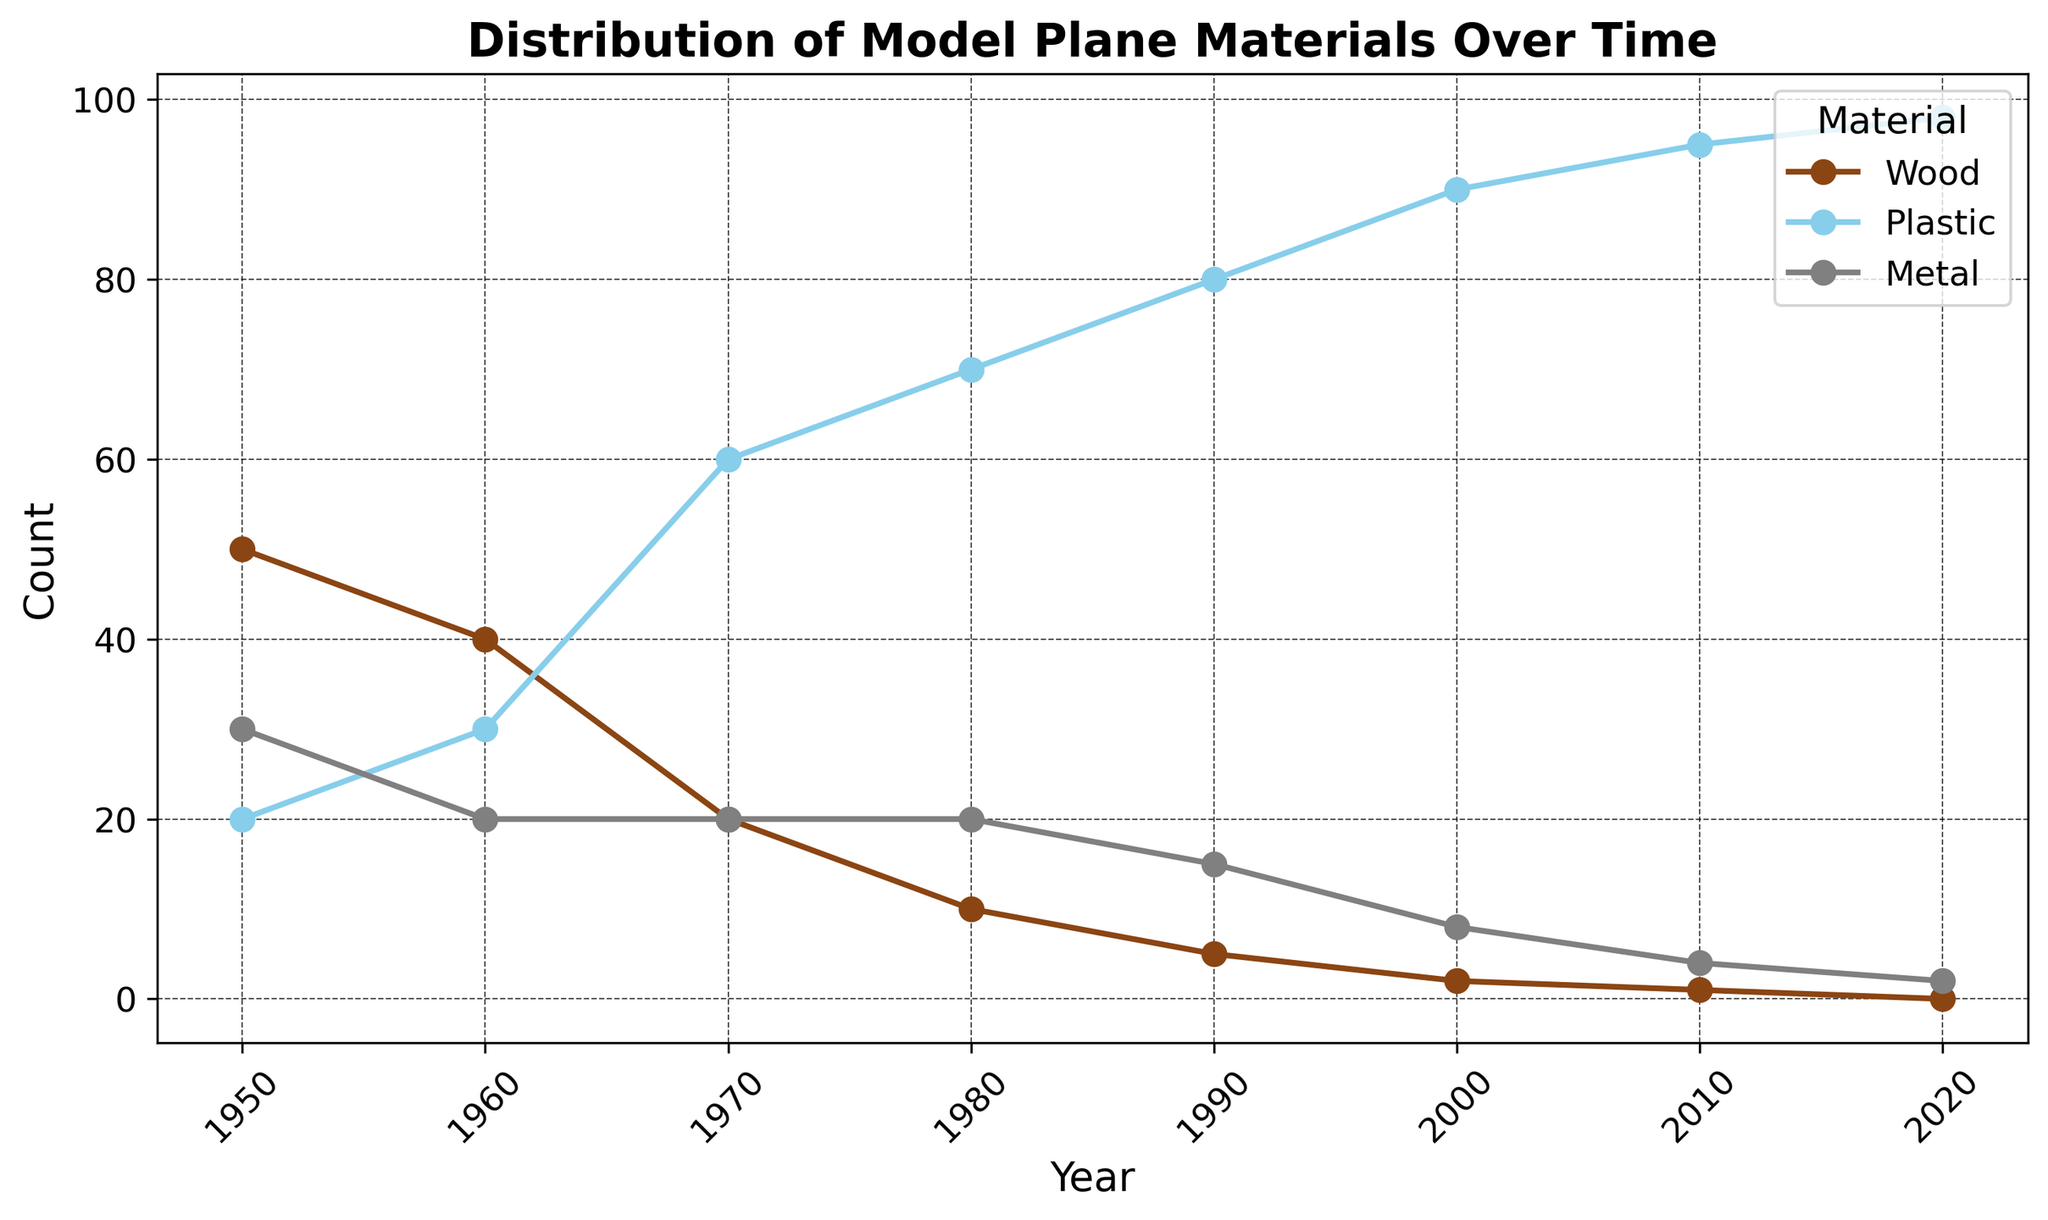What trend do you notice for the use of plastic materials from 1950 to 2020? By observing the height of the lines and position on the horizontal axis, we can see that the use of plastic materials has been increasing over the years. Starting from 20 in 1950, the count has consistently risen to 98 by 2020.
Answer: Increasing trend Which material was used the most around 1980? The height of the lines for different materials in 1980 can be compared. The line for plastic is much higher than those for wood and metal, indicating the use of plastic was the highest.
Answer: Plastic What is the overall trend in the usage of wood over the years? By looking across the years for wood at the different positions, the height of the markers starts high in 1950 and decreases steadily until it disappears by 2020. This suggests a consistent decline.
Answer: Declining trend During which decade did metal see an increase in its usage compared to the previous decade? The metal usage line should be observed to detect an increase at any point. Metal usage increased slightly from 1950 (30) to 1960 (20), but then it decreased or remained constant in subsequent decades.
Answer: No increase after 1950 What is the difference in the count of wood materials used between 1950 and 2020? The wood usage in 1950 is 50, and it drops to 0 in 2020. The difference between them is calculated as 50 - 0.
Answer: 50 Compare the usage of metal and plastic in 2010. Which one was used more? In 2010, the lines for both materials are observed. Plastic is at a count of 95, and metal at 4, showing plastic was used significantly more.
Answer: Plastic How does the use of plastic in 2020 compare to all other materials combined in 2020? Plastic is at 98 in 2020, whereas wood and metal combined are at 0 + 2 = 2. The combined count of other materials is much lower than plastic.
Answer: Plastic is greater What was the peak count value for plastic materials over the years, and in which year did it occur? The highest point on the line for plastic materials can be identified, which is 98. This peak occurred in 2020.
Answer: 98 in 2020 What is the yearly average count for metal usage across all provided years? The metal counts over the years are 30, 20, 20, 20, 15, 8, 4, 2. Adding these gives a total of 119. Dividing by the number of years (8) gives the average: 119/8 = 14.875.
Answer: 14.875 Which material saw the steepest decline in usage from 1950 to 2020? The slopes of the lines for all materials from 1950 to 2020 should be compared. Wood declines from 50 to 0, a drop of 50. Metal declines from 30 to 2, a drop of 28. Plastic, however, increases. Hence, wood experienced the steepest decline.
Answer: Wood 